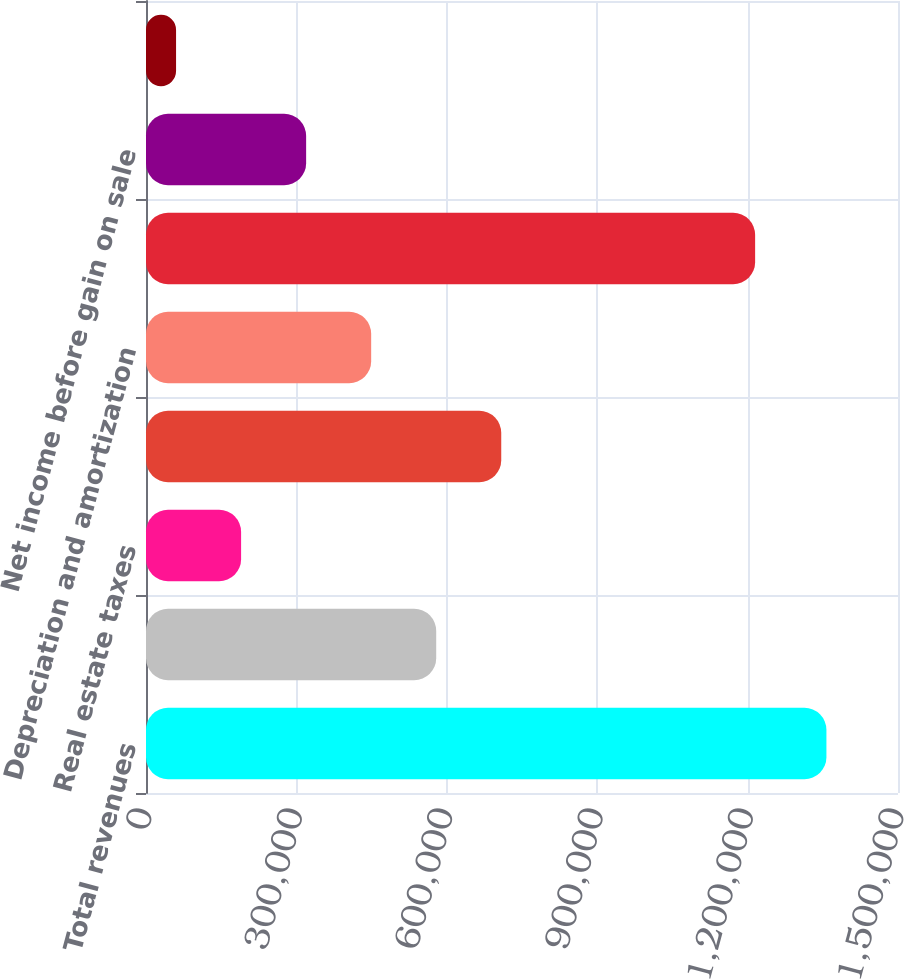Convert chart to OTSL. <chart><loc_0><loc_0><loc_500><loc_500><bar_chart><fcel>Total revenues<fcel>Operating expenses<fcel>Real estate taxes<fcel>Interest<fcel>Depreciation and amortization<fcel>Total expenses<fcel>Net income before gain on sale<fcel>Company's equity in net income<nl><fcel>1.35722e+06<fcel>578864<fcel>189687<fcel>708590<fcel>449138<fcel>1.21501e+06<fcel>319413<fcel>59961<nl></chart> 